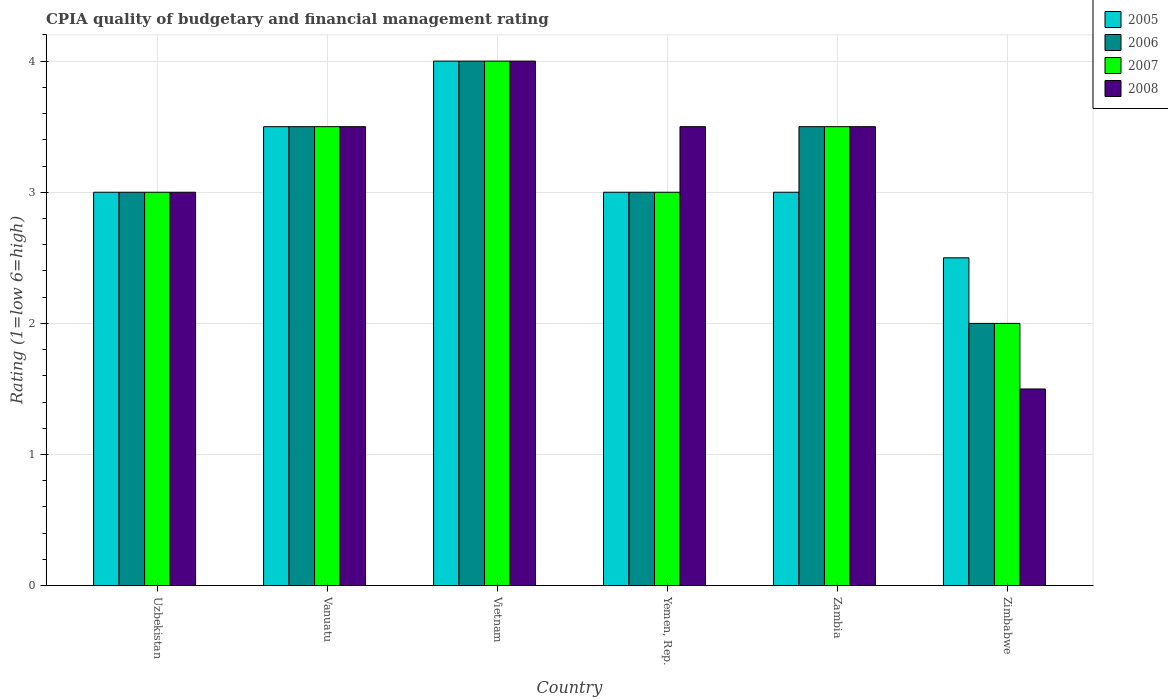How many different coloured bars are there?
Keep it short and to the point. 4. Are the number of bars per tick equal to the number of legend labels?
Give a very brief answer. Yes. How many bars are there on the 1st tick from the left?
Your response must be concise. 4. What is the label of the 2nd group of bars from the left?
Your answer should be compact. Vanuatu. In how many cases, is the number of bars for a given country not equal to the number of legend labels?
Provide a short and direct response. 0. Across all countries, what is the maximum CPIA rating in 2005?
Provide a short and direct response. 4. In which country was the CPIA rating in 2006 maximum?
Provide a succinct answer. Vietnam. In which country was the CPIA rating in 2006 minimum?
Your answer should be compact. Zimbabwe. What is the total CPIA rating in 2008 in the graph?
Provide a short and direct response. 19. What is the difference between the CPIA rating in 2005 in Zimbabwe and the CPIA rating in 2006 in Vietnam?
Ensure brevity in your answer.  -1.5. What is the average CPIA rating in 2005 per country?
Offer a terse response. 3.17. In how many countries, is the CPIA rating in 2006 greater than 0.6000000000000001?
Your response must be concise. 6. What is the ratio of the CPIA rating in 2008 in Vietnam to that in Yemen, Rep.?
Make the answer very short. 1.14. Is the CPIA rating in 2006 in Yemen, Rep. less than that in Zambia?
Your answer should be very brief. Yes. What is the difference between the highest and the second highest CPIA rating in 2008?
Give a very brief answer. -0.5. What is the difference between the highest and the lowest CPIA rating in 2007?
Your answer should be compact. 2. In how many countries, is the CPIA rating in 2008 greater than the average CPIA rating in 2008 taken over all countries?
Keep it short and to the point. 4. Is the sum of the CPIA rating in 2007 in Vietnam and Zimbabwe greater than the maximum CPIA rating in 2006 across all countries?
Your response must be concise. Yes. What does the 2nd bar from the left in Vanuatu represents?
Your answer should be compact. 2006. How many bars are there?
Provide a short and direct response. 24. How many countries are there in the graph?
Your answer should be very brief. 6. What is the difference between two consecutive major ticks on the Y-axis?
Offer a very short reply. 1. Does the graph contain grids?
Offer a very short reply. Yes. How many legend labels are there?
Your answer should be very brief. 4. What is the title of the graph?
Keep it short and to the point. CPIA quality of budgetary and financial management rating. Does "1974" appear as one of the legend labels in the graph?
Keep it short and to the point. No. What is the label or title of the Y-axis?
Provide a short and direct response. Rating (1=low 6=high). What is the Rating (1=low 6=high) in 2006 in Uzbekistan?
Your response must be concise. 3. What is the Rating (1=low 6=high) in 2007 in Uzbekistan?
Make the answer very short. 3. What is the Rating (1=low 6=high) of 2008 in Uzbekistan?
Offer a terse response. 3. What is the Rating (1=low 6=high) of 2006 in Vanuatu?
Your answer should be compact. 3.5. What is the Rating (1=low 6=high) of 2005 in Vietnam?
Give a very brief answer. 4. What is the Rating (1=low 6=high) of 2005 in Yemen, Rep.?
Keep it short and to the point. 3. What is the Rating (1=low 6=high) of 2006 in Yemen, Rep.?
Your response must be concise. 3. What is the Rating (1=low 6=high) in 2007 in Yemen, Rep.?
Your response must be concise. 3. What is the Rating (1=low 6=high) of 2008 in Yemen, Rep.?
Your response must be concise. 3.5. What is the Rating (1=low 6=high) of 2007 in Zambia?
Give a very brief answer. 3.5. What is the Rating (1=low 6=high) of 2008 in Zimbabwe?
Your answer should be very brief. 1.5. Across all countries, what is the maximum Rating (1=low 6=high) of 2005?
Ensure brevity in your answer.  4. Across all countries, what is the maximum Rating (1=low 6=high) of 2006?
Provide a short and direct response. 4. Across all countries, what is the minimum Rating (1=low 6=high) of 2005?
Give a very brief answer. 2.5. Across all countries, what is the minimum Rating (1=low 6=high) in 2008?
Keep it short and to the point. 1.5. What is the total Rating (1=low 6=high) of 2005 in the graph?
Offer a very short reply. 19. What is the total Rating (1=low 6=high) in 2006 in the graph?
Your response must be concise. 19. What is the total Rating (1=low 6=high) in 2007 in the graph?
Ensure brevity in your answer.  19. What is the total Rating (1=low 6=high) of 2008 in the graph?
Make the answer very short. 19. What is the difference between the Rating (1=low 6=high) in 2006 in Uzbekistan and that in Vanuatu?
Provide a succinct answer. -0.5. What is the difference between the Rating (1=low 6=high) in 2008 in Uzbekistan and that in Vanuatu?
Provide a short and direct response. -0.5. What is the difference between the Rating (1=low 6=high) in 2006 in Uzbekistan and that in Yemen, Rep.?
Make the answer very short. 0. What is the difference between the Rating (1=low 6=high) in 2006 in Uzbekistan and that in Zambia?
Provide a short and direct response. -0.5. What is the difference between the Rating (1=low 6=high) of 2008 in Uzbekistan and that in Zambia?
Give a very brief answer. -0.5. What is the difference between the Rating (1=low 6=high) of 2005 in Uzbekistan and that in Zimbabwe?
Your answer should be very brief. 0.5. What is the difference between the Rating (1=low 6=high) in 2006 in Uzbekistan and that in Zimbabwe?
Your response must be concise. 1. What is the difference between the Rating (1=low 6=high) of 2008 in Uzbekistan and that in Zimbabwe?
Offer a terse response. 1.5. What is the difference between the Rating (1=low 6=high) of 2006 in Vanuatu and that in Vietnam?
Offer a very short reply. -0.5. What is the difference between the Rating (1=low 6=high) in 2008 in Vanuatu and that in Yemen, Rep.?
Give a very brief answer. 0. What is the difference between the Rating (1=low 6=high) of 2005 in Vanuatu and that in Zambia?
Your answer should be very brief. 0.5. What is the difference between the Rating (1=low 6=high) in 2007 in Vanuatu and that in Zambia?
Make the answer very short. 0. What is the difference between the Rating (1=low 6=high) in 2006 in Vanuatu and that in Zimbabwe?
Provide a short and direct response. 1.5. What is the difference between the Rating (1=low 6=high) in 2007 in Vietnam and that in Yemen, Rep.?
Your response must be concise. 1. What is the difference between the Rating (1=low 6=high) in 2008 in Vietnam and that in Yemen, Rep.?
Keep it short and to the point. 0.5. What is the difference between the Rating (1=low 6=high) in 2005 in Vietnam and that in Zambia?
Provide a short and direct response. 1. What is the difference between the Rating (1=low 6=high) in 2007 in Vietnam and that in Zambia?
Your answer should be very brief. 0.5. What is the difference between the Rating (1=low 6=high) of 2008 in Vietnam and that in Zambia?
Make the answer very short. 0.5. What is the difference between the Rating (1=low 6=high) of 2008 in Vietnam and that in Zimbabwe?
Make the answer very short. 2.5. What is the difference between the Rating (1=low 6=high) of 2008 in Yemen, Rep. and that in Zambia?
Ensure brevity in your answer.  0. What is the difference between the Rating (1=low 6=high) of 2008 in Yemen, Rep. and that in Zimbabwe?
Your answer should be very brief. 2. What is the difference between the Rating (1=low 6=high) in 2005 in Zambia and that in Zimbabwe?
Make the answer very short. 0.5. What is the difference between the Rating (1=low 6=high) of 2006 in Zambia and that in Zimbabwe?
Give a very brief answer. 1.5. What is the difference between the Rating (1=low 6=high) of 2007 in Zambia and that in Zimbabwe?
Make the answer very short. 1.5. What is the difference between the Rating (1=low 6=high) of 2008 in Zambia and that in Zimbabwe?
Provide a short and direct response. 2. What is the difference between the Rating (1=low 6=high) in 2005 in Uzbekistan and the Rating (1=low 6=high) in 2006 in Vanuatu?
Offer a very short reply. -0.5. What is the difference between the Rating (1=low 6=high) of 2005 in Uzbekistan and the Rating (1=low 6=high) of 2007 in Vanuatu?
Your response must be concise. -0.5. What is the difference between the Rating (1=low 6=high) in 2005 in Uzbekistan and the Rating (1=low 6=high) in 2008 in Vanuatu?
Your answer should be compact. -0.5. What is the difference between the Rating (1=low 6=high) of 2005 in Uzbekistan and the Rating (1=low 6=high) of 2006 in Vietnam?
Give a very brief answer. -1. What is the difference between the Rating (1=low 6=high) of 2005 in Uzbekistan and the Rating (1=low 6=high) of 2007 in Vietnam?
Offer a terse response. -1. What is the difference between the Rating (1=low 6=high) of 2005 in Uzbekistan and the Rating (1=low 6=high) of 2008 in Vietnam?
Give a very brief answer. -1. What is the difference between the Rating (1=low 6=high) of 2006 in Uzbekistan and the Rating (1=low 6=high) of 2008 in Vietnam?
Offer a very short reply. -1. What is the difference between the Rating (1=low 6=high) in 2007 in Uzbekistan and the Rating (1=low 6=high) in 2008 in Vietnam?
Ensure brevity in your answer.  -1. What is the difference between the Rating (1=low 6=high) in 2005 in Uzbekistan and the Rating (1=low 6=high) in 2007 in Zambia?
Your answer should be compact. -0.5. What is the difference between the Rating (1=low 6=high) in 2005 in Uzbekistan and the Rating (1=low 6=high) in 2008 in Zambia?
Offer a very short reply. -0.5. What is the difference between the Rating (1=low 6=high) in 2006 in Uzbekistan and the Rating (1=low 6=high) in 2008 in Zambia?
Give a very brief answer. -0.5. What is the difference between the Rating (1=low 6=high) in 2007 in Uzbekistan and the Rating (1=low 6=high) in 2008 in Zambia?
Offer a very short reply. -0.5. What is the difference between the Rating (1=low 6=high) in 2005 in Uzbekistan and the Rating (1=low 6=high) in 2007 in Zimbabwe?
Offer a very short reply. 1. What is the difference between the Rating (1=low 6=high) of 2005 in Uzbekistan and the Rating (1=low 6=high) of 2008 in Zimbabwe?
Keep it short and to the point. 1.5. What is the difference between the Rating (1=low 6=high) in 2006 in Uzbekistan and the Rating (1=low 6=high) in 2007 in Zimbabwe?
Your response must be concise. 1. What is the difference between the Rating (1=low 6=high) of 2006 in Uzbekistan and the Rating (1=low 6=high) of 2008 in Zimbabwe?
Make the answer very short. 1.5. What is the difference between the Rating (1=low 6=high) in 2007 in Uzbekistan and the Rating (1=low 6=high) in 2008 in Zimbabwe?
Your answer should be compact. 1.5. What is the difference between the Rating (1=low 6=high) of 2005 in Vanuatu and the Rating (1=low 6=high) of 2007 in Vietnam?
Ensure brevity in your answer.  -0.5. What is the difference between the Rating (1=low 6=high) of 2005 in Vanuatu and the Rating (1=low 6=high) of 2008 in Vietnam?
Provide a short and direct response. -0.5. What is the difference between the Rating (1=low 6=high) in 2006 in Vanuatu and the Rating (1=low 6=high) in 2008 in Vietnam?
Your answer should be compact. -0.5. What is the difference between the Rating (1=low 6=high) in 2005 in Vanuatu and the Rating (1=low 6=high) in 2006 in Yemen, Rep.?
Provide a succinct answer. 0.5. What is the difference between the Rating (1=low 6=high) of 2005 in Vanuatu and the Rating (1=low 6=high) of 2007 in Yemen, Rep.?
Your answer should be very brief. 0.5. What is the difference between the Rating (1=low 6=high) in 2005 in Vanuatu and the Rating (1=low 6=high) in 2008 in Yemen, Rep.?
Provide a succinct answer. 0. What is the difference between the Rating (1=low 6=high) in 2006 in Vanuatu and the Rating (1=low 6=high) in 2007 in Yemen, Rep.?
Give a very brief answer. 0.5. What is the difference between the Rating (1=low 6=high) of 2006 in Vanuatu and the Rating (1=low 6=high) of 2008 in Yemen, Rep.?
Ensure brevity in your answer.  0. What is the difference between the Rating (1=low 6=high) in 2005 in Vanuatu and the Rating (1=low 6=high) in 2006 in Zambia?
Keep it short and to the point. 0. What is the difference between the Rating (1=low 6=high) in 2005 in Vanuatu and the Rating (1=low 6=high) in 2007 in Zambia?
Your response must be concise. 0. What is the difference between the Rating (1=low 6=high) of 2005 in Vanuatu and the Rating (1=low 6=high) of 2008 in Zambia?
Provide a succinct answer. 0. What is the difference between the Rating (1=low 6=high) in 2006 in Vanuatu and the Rating (1=low 6=high) in 2008 in Zambia?
Your response must be concise. 0. What is the difference between the Rating (1=low 6=high) of 2007 in Vanuatu and the Rating (1=low 6=high) of 2008 in Zambia?
Your answer should be very brief. 0. What is the difference between the Rating (1=low 6=high) in 2005 in Vanuatu and the Rating (1=low 6=high) in 2007 in Zimbabwe?
Make the answer very short. 1.5. What is the difference between the Rating (1=low 6=high) of 2005 in Vanuatu and the Rating (1=low 6=high) of 2008 in Zimbabwe?
Make the answer very short. 2. What is the difference between the Rating (1=low 6=high) of 2006 in Vanuatu and the Rating (1=low 6=high) of 2008 in Zimbabwe?
Give a very brief answer. 2. What is the difference between the Rating (1=low 6=high) of 2007 in Vanuatu and the Rating (1=low 6=high) of 2008 in Zimbabwe?
Provide a succinct answer. 2. What is the difference between the Rating (1=low 6=high) of 2005 in Vietnam and the Rating (1=low 6=high) of 2007 in Yemen, Rep.?
Provide a short and direct response. 1. What is the difference between the Rating (1=low 6=high) in 2006 in Vietnam and the Rating (1=low 6=high) in 2007 in Yemen, Rep.?
Your answer should be very brief. 1. What is the difference between the Rating (1=low 6=high) in 2005 in Vietnam and the Rating (1=low 6=high) in 2007 in Zambia?
Ensure brevity in your answer.  0.5. What is the difference between the Rating (1=low 6=high) of 2007 in Vietnam and the Rating (1=low 6=high) of 2008 in Zambia?
Offer a very short reply. 0.5. What is the difference between the Rating (1=low 6=high) in 2005 in Vietnam and the Rating (1=low 6=high) in 2007 in Zimbabwe?
Offer a terse response. 2. What is the difference between the Rating (1=low 6=high) in 2005 in Vietnam and the Rating (1=low 6=high) in 2008 in Zimbabwe?
Provide a short and direct response. 2.5. What is the difference between the Rating (1=low 6=high) in 2006 in Vietnam and the Rating (1=low 6=high) in 2008 in Zimbabwe?
Ensure brevity in your answer.  2.5. What is the difference between the Rating (1=low 6=high) in 2007 in Vietnam and the Rating (1=low 6=high) in 2008 in Zimbabwe?
Ensure brevity in your answer.  2.5. What is the difference between the Rating (1=low 6=high) in 2005 in Yemen, Rep. and the Rating (1=low 6=high) in 2006 in Zambia?
Your answer should be very brief. -0.5. What is the difference between the Rating (1=low 6=high) in 2006 in Yemen, Rep. and the Rating (1=low 6=high) in 2008 in Zambia?
Provide a short and direct response. -0.5. What is the difference between the Rating (1=low 6=high) in 2005 in Yemen, Rep. and the Rating (1=low 6=high) in 2006 in Zimbabwe?
Your response must be concise. 1. What is the difference between the Rating (1=low 6=high) in 2006 in Yemen, Rep. and the Rating (1=low 6=high) in 2007 in Zimbabwe?
Keep it short and to the point. 1. What is the difference between the Rating (1=low 6=high) in 2005 in Zambia and the Rating (1=low 6=high) in 2008 in Zimbabwe?
Your answer should be compact. 1.5. What is the average Rating (1=low 6=high) in 2005 per country?
Give a very brief answer. 3.17. What is the average Rating (1=low 6=high) in 2006 per country?
Offer a very short reply. 3.17. What is the average Rating (1=low 6=high) of 2007 per country?
Offer a very short reply. 3.17. What is the average Rating (1=low 6=high) in 2008 per country?
Make the answer very short. 3.17. What is the difference between the Rating (1=low 6=high) in 2005 and Rating (1=low 6=high) in 2006 in Uzbekistan?
Your response must be concise. 0. What is the difference between the Rating (1=low 6=high) of 2005 and Rating (1=low 6=high) of 2008 in Uzbekistan?
Offer a terse response. 0. What is the difference between the Rating (1=low 6=high) of 2006 and Rating (1=low 6=high) of 2008 in Uzbekistan?
Offer a very short reply. 0. What is the difference between the Rating (1=low 6=high) of 2005 and Rating (1=low 6=high) of 2007 in Vanuatu?
Keep it short and to the point. 0. What is the difference between the Rating (1=low 6=high) of 2006 and Rating (1=low 6=high) of 2007 in Vanuatu?
Offer a terse response. 0. What is the difference between the Rating (1=low 6=high) of 2006 and Rating (1=low 6=high) of 2008 in Vanuatu?
Keep it short and to the point. 0. What is the difference between the Rating (1=low 6=high) in 2006 and Rating (1=low 6=high) in 2008 in Vietnam?
Ensure brevity in your answer.  0. What is the difference between the Rating (1=low 6=high) of 2005 and Rating (1=low 6=high) of 2007 in Yemen, Rep.?
Keep it short and to the point. 0. What is the difference between the Rating (1=low 6=high) of 2005 and Rating (1=low 6=high) of 2008 in Yemen, Rep.?
Give a very brief answer. -0.5. What is the difference between the Rating (1=low 6=high) of 2006 and Rating (1=low 6=high) of 2008 in Yemen, Rep.?
Your answer should be compact. -0.5. What is the difference between the Rating (1=low 6=high) in 2006 and Rating (1=low 6=high) in 2007 in Zambia?
Your answer should be very brief. 0. What is the difference between the Rating (1=low 6=high) in 2005 and Rating (1=low 6=high) in 2006 in Zimbabwe?
Provide a succinct answer. 0.5. What is the difference between the Rating (1=low 6=high) in 2005 and Rating (1=low 6=high) in 2007 in Zimbabwe?
Keep it short and to the point. 0.5. What is the difference between the Rating (1=low 6=high) in 2005 and Rating (1=low 6=high) in 2008 in Zimbabwe?
Provide a short and direct response. 1. What is the difference between the Rating (1=low 6=high) of 2006 and Rating (1=low 6=high) of 2007 in Zimbabwe?
Your answer should be very brief. 0. What is the difference between the Rating (1=low 6=high) in 2007 and Rating (1=low 6=high) in 2008 in Zimbabwe?
Keep it short and to the point. 0.5. What is the ratio of the Rating (1=low 6=high) in 2005 in Uzbekistan to that in Vietnam?
Your answer should be compact. 0.75. What is the ratio of the Rating (1=low 6=high) of 2006 in Uzbekistan to that in Zambia?
Ensure brevity in your answer.  0.86. What is the ratio of the Rating (1=low 6=high) in 2007 in Uzbekistan to that in Zambia?
Give a very brief answer. 0.86. What is the ratio of the Rating (1=low 6=high) in 2005 in Uzbekistan to that in Zimbabwe?
Your answer should be very brief. 1.2. What is the ratio of the Rating (1=low 6=high) in 2007 in Uzbekistan to that in Zimbabwe?
Ensure brevity in your answer.  1.5. What is the ratio of the Rating (1=low 6=high) of 2007 in Vanuatu to that in Vietnam?
Offer a very short reply. 0.88. What is the ratio of the Rating (1=low 6=high) in 2008 in Vanuatu to that in Vietnam?
Provide a succinct answer. 0.88. What is the ratio of the Rating (1=low 6=high) in 2006 in Vanuatu to that in Yemen, Rep.?
Your response must be concise. 1.17. What is the ratio of the Rating (1=low 6=high) in 2007 in Vanuatu to that in Yemen, Rep.?
Ensure brevity in your answer.  1.17. What is the ratio of the Rating (1=low 6=high) in 2006 in Vanuatu to that in Zambia?
Provide a short and direct response. 1. What is the ratio of the Rating (1=low 6=high) of 2008 in Vanuatu to that in Zambia?
Your answer should be very brief. 1. What is the ratio of the Rating (1=low 6=high) in 2005 in Vanuatu to that in Zimbabwe?
Your response must be concise. 1.4. What is the ratio of the Rating (1=low 6=high) in 2008 in Vanuatu to that in Zimbabwe?
Provide a succinct answer. 2.33. What is the ratio of the Rating (1=low 6=high) in 2005 in Vietnam to that in Yemen, Rep.?
Your answer should be very brief. 1.33. What is the ratio of the Rating (1=low 6=high) of 2008 in Vietnam to that in Yemen, Rep.?
Provide a succinct answer. 1.14. What is the ratio of the Rating (1=low 6=high) in 2005 in Vietnam to that in Zambia?
Offer a terse response. 1.33. What is the ratio of the Rating (1=low 6=high) in 2006 in Vietnam to that in Zambia?
Ensure brevity in your answer.  1.14. What is the ratio of the Rating (1=low 6=high) in 2006 in Vietnam to that in Zimbabwe?
Ensure brevity in your answer.  2. What is the ratio of the Rating (1=low 6=high) of 2008 in Vietnam to that in Zimbabwe?
Keep it short and to the point. 2.67. What is the ratio of the Rating (1=low 6=high) in 2006 in Yemen, Rep. to that in Zimbabwe?
Provide a short and direct response. 1.5. What is the ratio of the Rating (1=low 6=high) in 2007 in Yemen, Rep. to that in Zimbabwe?
Offer a terse response. 1.5. What is the ratio of the Rating (1=low 6=high) in 2008 in Yemen, Rep. to that in Zimbabwe?
Give a very brief answer. 2.33. What is the ratio of the Rating (1=low 6=high) in 2007 in Zambia to that in Zimbabwe?
Provide a short and direct response. 1.75. What is the ratio of the Rating (1=low 6=high) in 2008 in Zambia to that in Zimbabwe?
Your answer should be very brief. 2.33. What is the difference between the highest and the second highest Rating (1=low 6=high) of 2005?
Offer a very short reply. 0.5. What is the difference between the highest and the lowest Rating (1=low 6=high) in 2005?
Your response must be concise. 1.5. What is the difference between the highest and the lowest Rating (1=low 6=high) in 2006?
Your answer should be very brief. 2. What is the difference between the highest and the lowest Rating (1=low 6=high) of 2008?
Make the answer very short. 2.5. 